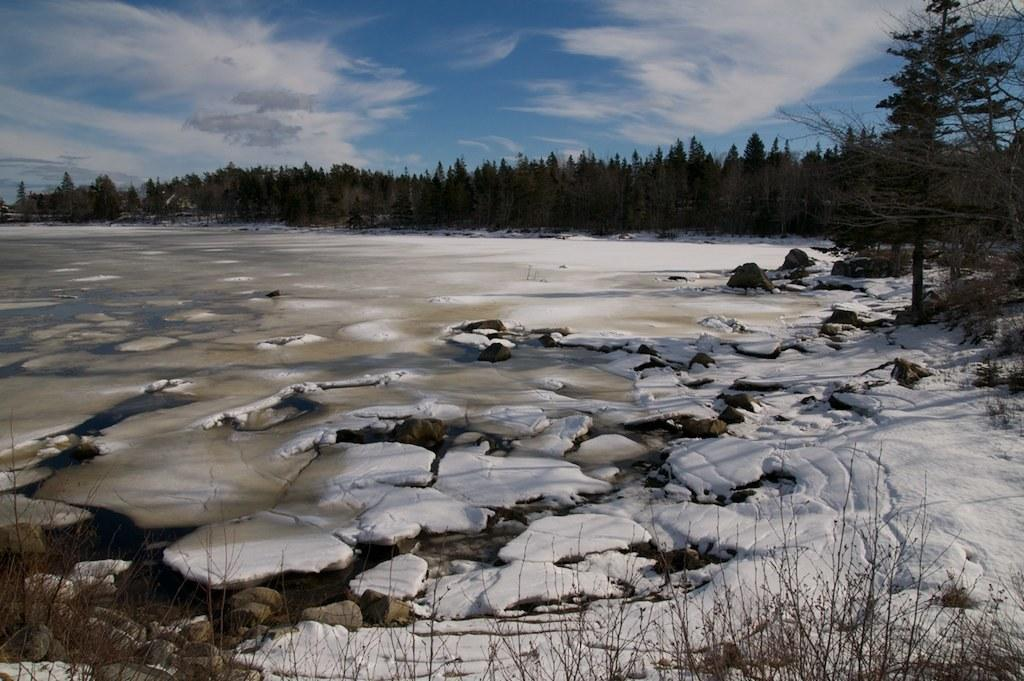What type of weather condition is depicted in the image? There is snow in the image, which suggests a wintery or cold weather condition. What type of vegetation is visible in the image? There are trees in the image. What is visible in the background of the image? The sky with clouds is visible in the background of the image. What type of blood is visible on the trees in the image? There is no blood visible on the trees in the image; it only shows snow and trees. What type of flight is taking place in the image? There is no flight or any indication of a flight in the image. 